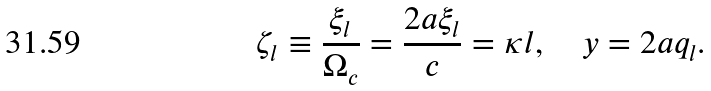Convert formula to latex. <formula><loc_0><loc_0><loc_500><loc_500>\zeta _ { l } \equiv \frac { \xi _ { l } } { \Omega _ { c } } = \frac { 2 a \xi _ { l } } { c } = \kappa l , \quad y = 2 a q _ { l } .</formula> 